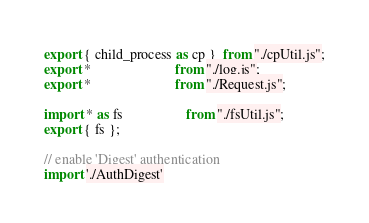Convert code to text. <code><loc_0><loc_0><loc_500><loc_500><_TypeScript_>export { child_process as cp }  from "./cpUtil.js";
export *                        from "./log.js";
export *                        from "./Request.js";

import * as fs                  from "./fsUtil.js";
export { fs };

// enable 'Digest' authentication
import './AuthDigest'
</code> 